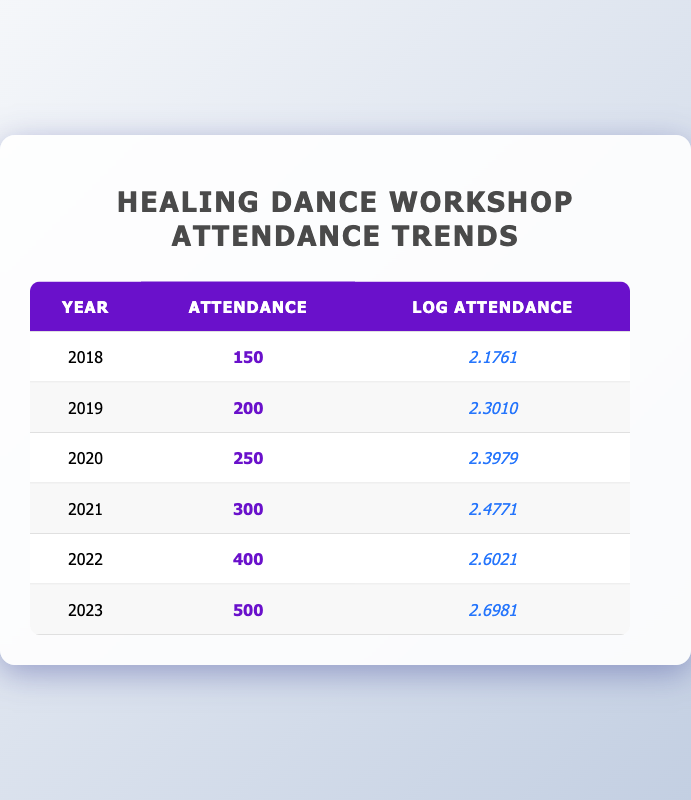What was the attendance in 2020? In the row for the year 2020, the attendance is listed directly in the table as 250.
Answer: 250 How many more attendees were there in 2023 compared to 2018? To find the difference, subtract the attendance in 2018 from that in 2023: 500 (2023) - 150 (2018) = 350.
Answer: 350 What was the average attendance from 2018 to 2023? To calculate the average attendance, add the attendance values from all years: 150 + 200 + 250 + 300 + 400 + 500 = 1800. Then, divide by the number of years (6): 1800 / 6 = 300.
Answer: 300 Is the log attendance for 2021 greater than 2.5? Looking at the log attendance for 2021, which is 2.4771, it is less than 2.5. Thus, the statement is false.
Answer: No In which year did the attendance first exceed 400? According to the table, the attendance exceeds 400 for the first time in 2022, where it is listed as 400.
Answer: 2022 By how much did the attendance increase from 2019 to 2021? The attendance in 2019 was 200, and in 2021 it was 300. The increase is calculated as 300 - 200 = 100.
Answer: 100 Is it true that attendance in 2023 is double that of 2018? The attendance for 2018 is 150, and for 2023 it is 500. Double of 150 is 300, thus 500 is greater than 300, making the statement true.
Answer: Yes What is the difference in log attendance between 2022 and 2023? The log attendance for 2022 is 2.6021 and for 2023 is 2.6981. To find the difference, subtract: 2.6981 - 2.6021 = 0.096.
Answer: 0.096 In which year was the attendance the lowest? The lowest attendance is found in the year 2018, which is listed as 150.
Answer: 2018 